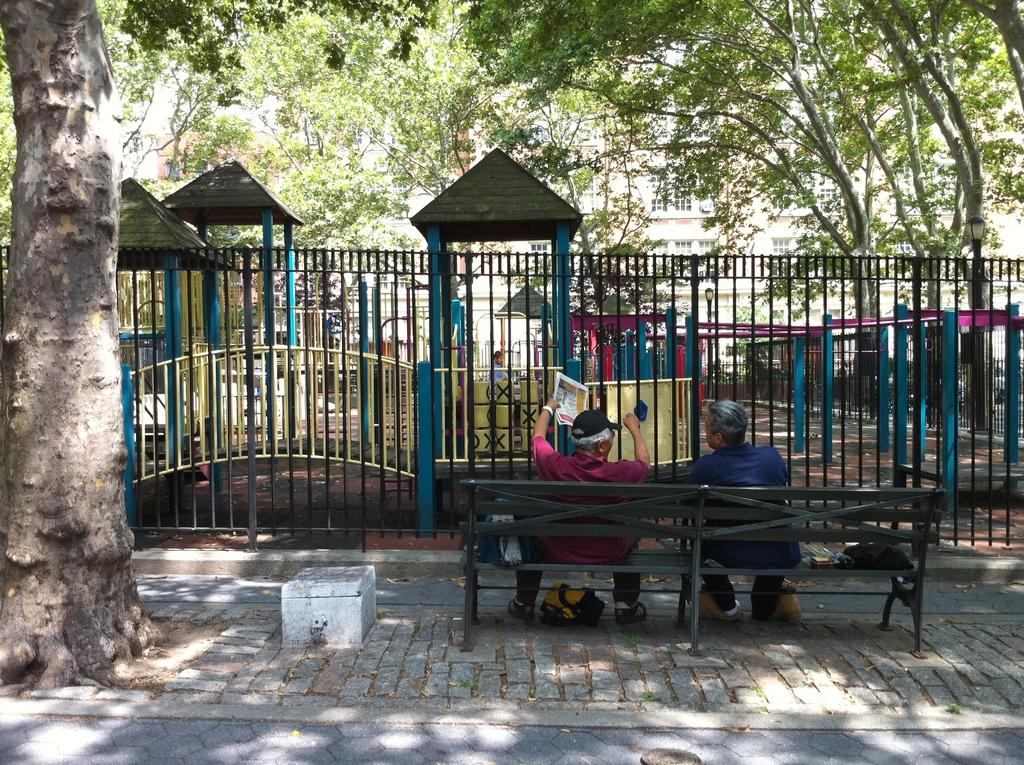How many people are sitting on the bench in the image? There are two persons sitting on a bench in the image. What is one of the persons holding? One of the persons is holding papers. What type of vegetation can be seen in the image? There are trees in the image. What architectural feature is present in the image? There is a railing in the image. What type of buildings can be seen in the image? There is a house and wooden huts in the image. What type of silk is draped over the wooden huts in the image? There is no silk present in the image; it features a bench with two people, trees, a railing, a house, and wooden huts. 